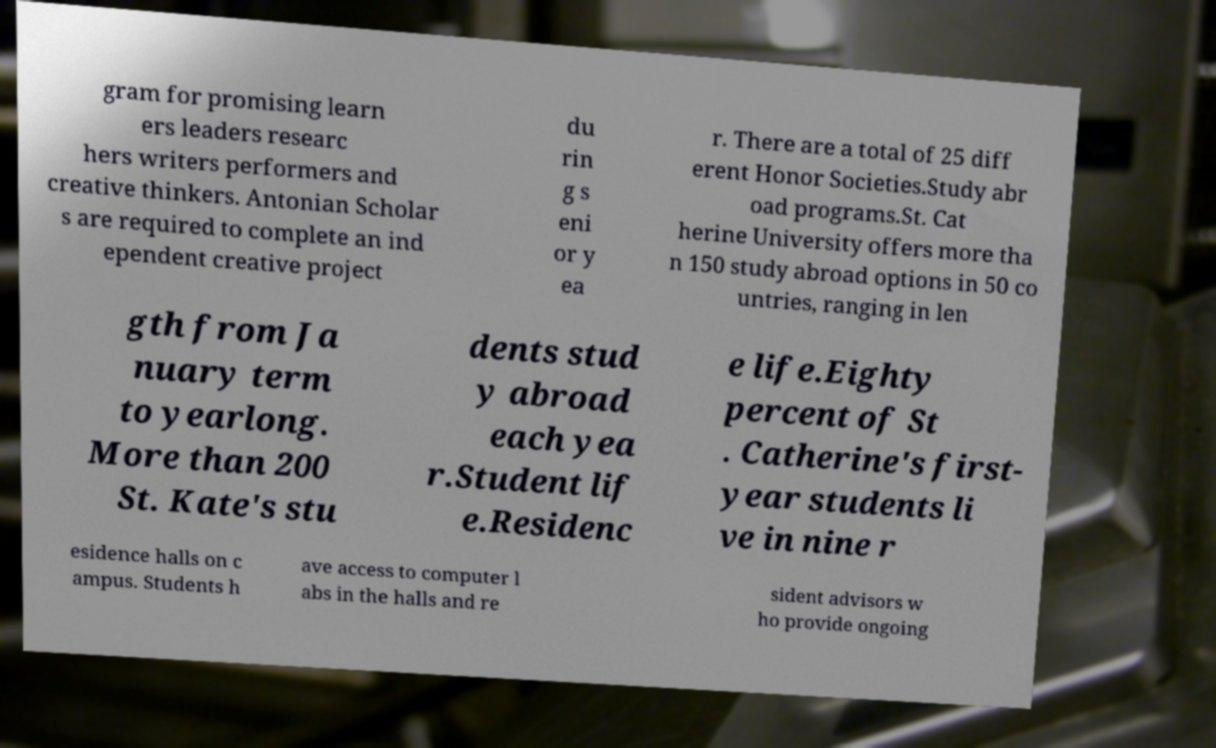I need the written content from this picture converted into text. Can you do that? gram for promising learn ers leaders researc hers writers performers and creative thinkers. Antonian Scholar s are required to complete an ind ependent creative project du rin g s eni or y ea r. There are a total of 25 diff erent Honor Societies.Study abr oad programs.St. Cat herine University offers more tha n 150 study abroad options in 50 co untries, ranging in len gth from Ja nuary term to yearlong. More than 200 St. Kate's stu dents stud y abroad each yea r.Student lif e.Residenc e life.Eighty percent of St . Catherine's first- year students li ve in nine r esidence halls on c ampus. Students h ave access to computer l abs in the halls and re sident advisors w ho provide ongoing 